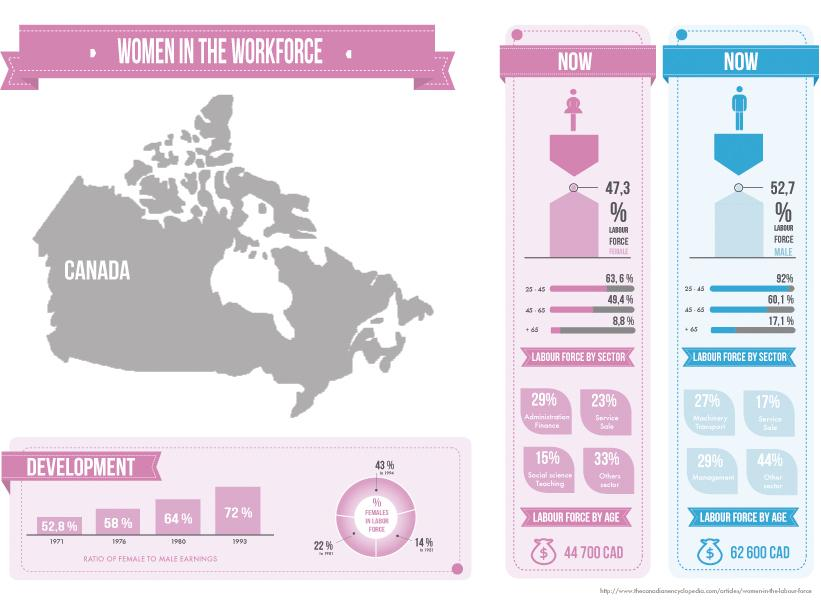Specify some key components in this picture. Approximately 49.4% of women aged 45-65 years are currently participating in the labour force of Canada. In 1993, the female-to-male earnings ratio in Canada was 72%. This means that, on average, women earned 72 cents for every dollar earned by men in the same job. This disparity in earnings highlights the ongoing gender pay gap that exists in Canada and around the world. Despite progress in recent years, women still earn less than men for similar work, and this disparity has significant impacts on women's economic security and overall well-being. In Canada, 17.1% of men aged 65 and older are part of the labor force. According to statistics, 47.3% of women are involved in the labour force of Canada. In 1976, the percentage ratio of female to male earnings in Canada was 58%. 